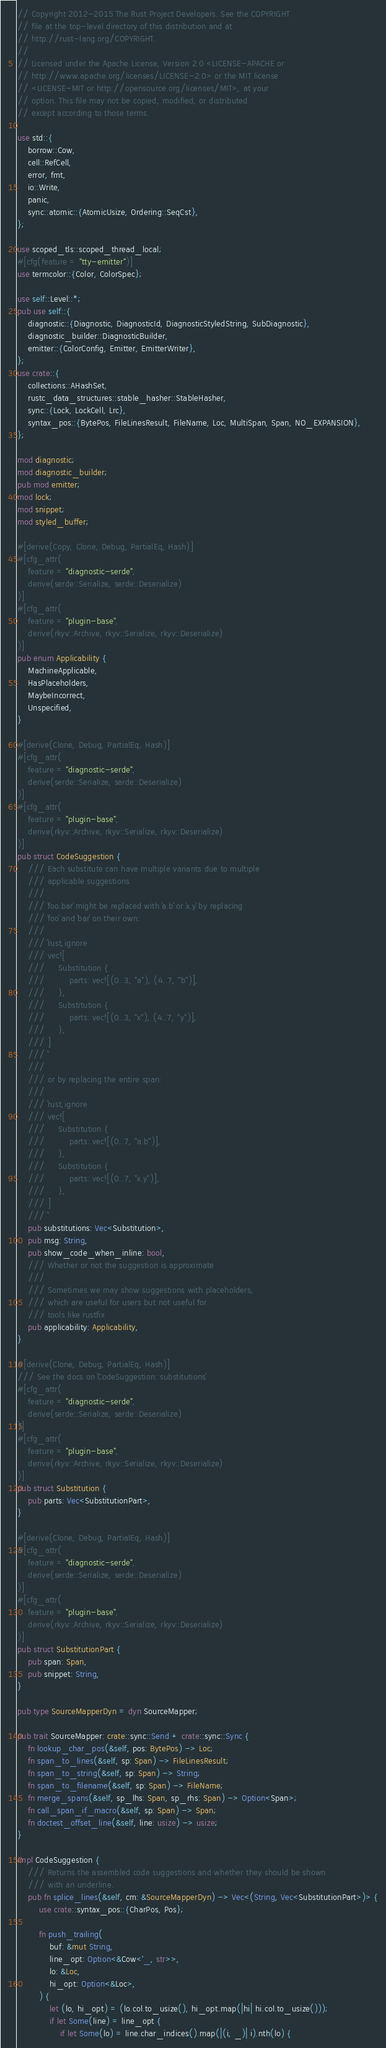<code> <loc_0><loc_0><loc_500><loc_500><_Rust_>// Copyright 2012-2015 The Rust Project Developers. See the COPYRIGHT
// file at the top-level directory of this distribution and at
// http://rust-lang.org/COPYRIGHT.
//
// Licensed under the Apache License, Version 2.0 <LICENSE-APACHE or
// http://www.apache.org/licenses/LICENSE-2.0> or the MIT license
// <LICENSE-MIT or http://opensource.org/licenses/MIT>, at your
// option. This file may not be copied, modified, or distributed
// except according to those terms.

use std::{
    borrow::Cow,
    cell::RefCell,
    error, fmt,
    io::Write,
    panic,
    sync::atomic::{AtomicUsize, Ordering::SeqCst},
};

use scoped_tls::scoped_thread_local;
#[cfg(feature = "tty-emitter")]
use termcolor::{Color, ColorSpec};

use self::Level::*;
pub use self::{
    diagnostic::{Diagnostic, DiagnosticId, DiagnosticStyledString, SubDiagnostic},
    diagnostic_builder::DiagnosticBuilder,
    emitter::{ColorConfig, Emitter, EmitterWriter},
};
use crate::{
    collections::AHashSet,
    rustc_data_structures::stable_hasher::StableHasher,
    sync::{Lock, LockCell, Lrc},
    syntax_pos::{BytePos, FileLinesResult, FileName, Loc, MultiSpan, Span, NO_EXPANSION},
};

mod diagnostic;
mod diagnostic_builder;
pub mod emitter;
mod lock;
mod snippet;
mod styled_buffer;

#[derive(Copy, Clone, Debug, PartialEq, Hash)]
#[cfg_attr(
    feature = "diagnostic-serde",
    derive(serde::Serialize, serde::Deserialize)
)]
#[cfg_attr(
    feature = "plugin-base",
    derive(rkyv::Archive, rkyv::Serialize, rkyv::Deserialize)
)]
pub enum Applicability {
    MachineApplicable,
    HasPlaceholders,
    MaybeIncorrect,
    Unspecified,
}

#[derive(Clone, Debug, PartialEq, Hash)]
#[cfg_attr(
    feature = "diagnostic-serde",
    derive(serde::Serialize, serde::Deserialize)
)]
#[cfg_attr(
    feature = "plugin-base",
    derive(rkyv::Archive, rkyv::Serialize, rkyv::Deserialize)
)]
pub struct CodeSuggestion {
    /// Each substitute can have multiple variants due to multiple
    /// applicable suggestions
    ///
    /// `foo.bar` might be replaced with `a.b` or `x.y` by replacing
    /// `foo` and `bar` on their own:
    ///
    /// ```rust,ignore
    /// vec![
    ///     Substitution {
    ///         parts: vec![(0..3, "a"), (4..7, "b")],
    ///     },
    ///     Substitution {
    ///         parts: vec![(0..3, "x"), (4..7, "y")],
    ///     },
    /// ]
    /// ```
    ///
    /// or by replacing the entire span:
    ///
    /// ```rust,ignore
    /// vec![
    ///     Substitution {
    ///         parts: vec![(0..7, "a.b")],
    ///     },
    ///     Substitution {
    ///         parts: vec![(0..7, "x.y")],
    ///     },
    /// ]
    /// ```
    pub substitutions: Vec<Substitution>,
    pub msg: String,
    pub show_code_when_inline: bool,
    /// Whether or not the suggestion is approximate
    ///
    /// Sometimes we may show suggestions with placeholders,
    /// which are useful for users but not useful for
    /// tools like rustfix
    pub applicability: Applicability,
}

#[derive(Clone, Debug, PartialEq, Hash)]
/// See the docs on `CodeSuggestion::substitutions`
#[cfg_attr(
    feature = "diagnostic-serde",
    derive(serde::Serialize, serde::Deserialize)
)]
#[cfg_attr(
    feature = "plugin-base",
    derive(rkyv::Archive, rkyv::Serialize, rkyv::Deserialize)
)]
pub struct Substitution {
    pub parts: Vec<SubstitutionPart>,
}

#[derive(Clone, Debug, PartialEq, Hash)]
#[cfg_attr(
    feature = "diagnostic-serde",
    derive(serde::Serialize, serde::Deserialize)
)]
#[cfg_attr(
    feature = "plugin-base",
    derive(rkyv::Archive, rkyv::Serialize, rkyv::Deserialize)
)]
pub struct SubstitutionPart {
    pub span: Span,
    pub snippet: String,
}

pub type SourceMapperDyn = dyn SourceMapper;

pub trait SourceMapper: crate::sync::Send + crate::sync::Sync {
    fn lookup_char_pos(&self, pos: BytePos) -> Loc;
    fn span_to_lines(&self, sp: Span) -> FileLinesResult;
    fn span_to_string(&self, sp: Span) -> String;
    fn span_to_filename(&self, sp: Span) -> FileName;
    fn merge_spans(&self, sp_lhs: Span, sp_rhs: Span) -> Option<Span>;
    fn call_span_if_macro(&self, sp: Span) -> Span;
    fn doctest_offset_line(&self, line: usize) -> usize;
}

impl CodeSuggestion {
    /// Returns the assembled code suggestions and whether they should be shown
    /// with an underline.
    pub fn splice_lines(&self, cm: &SourceMapperDyn) -> Vec<(String, Vec<SubstitutionPart>)> {
        use crate::syntax_pos::{CharPos, Pos};

        fn push_trailing(
            buf: &mut String,
            line_opt: Option<&Cow<'_, str>>,
            lo: &Loc,
            hi_opt: Option<&Loc>,
        ) {
            let (lo, hi_opt) = (lo.col.to_usize(), hi_opt.map(|hi| hi.col.to_usize()));
            if let Some(line) = line_opt {
                if let Some(lo) = line.char_indices().map(|(i, _)| i).nth(lo) {</code> 